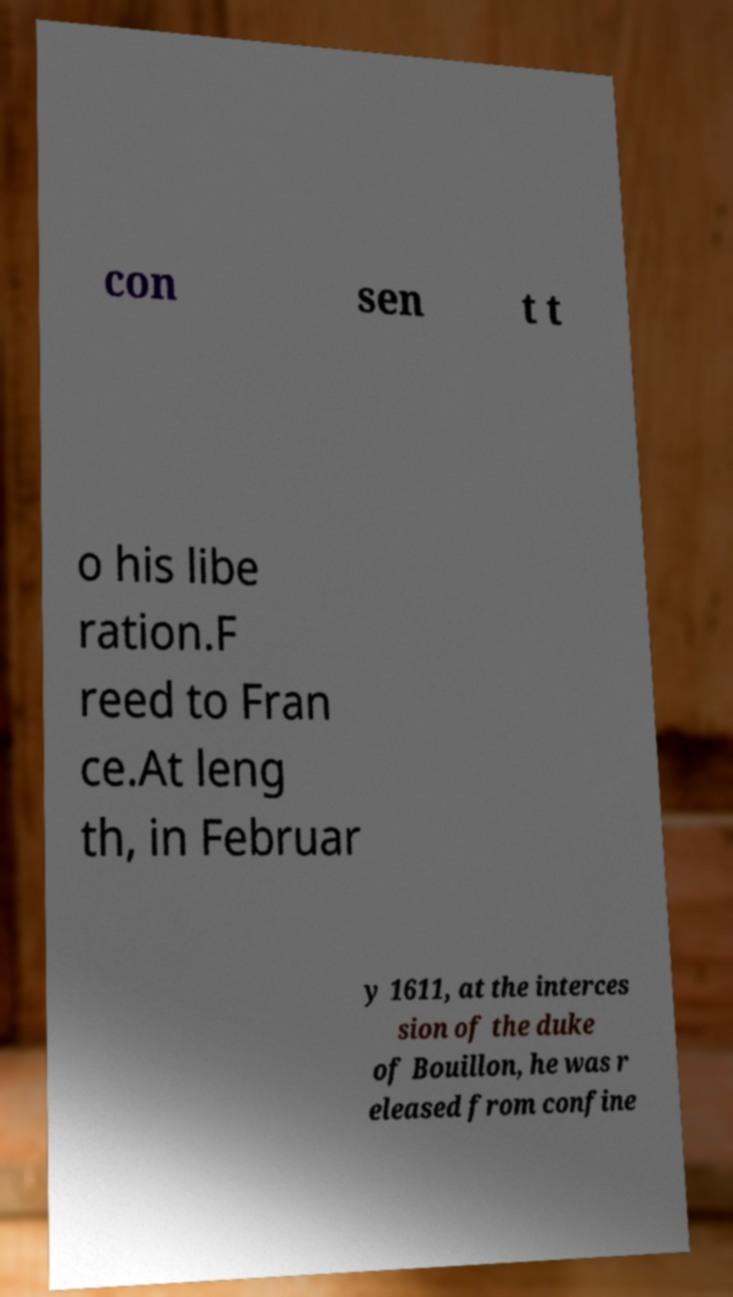I need the written content from this picture converted into text. Can you do that? con sen t t o his libe ration.F reed to Fran ce.At leng th, in Februar y 1611, at the interces sion of the duke of Bouillon, he was r eleased from confine 